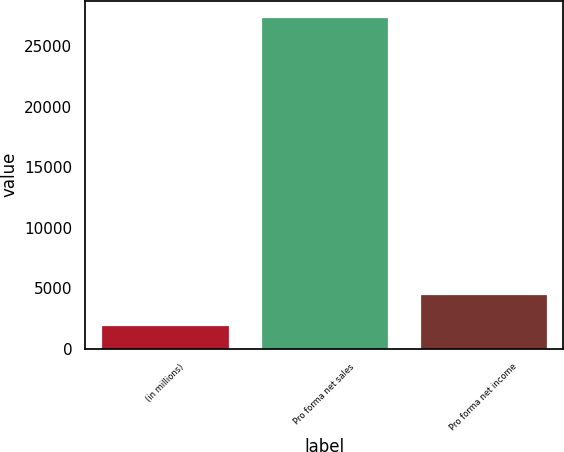Convert chart. <chart><loc_0><loc_0><loc_500><loc_500><bar_chart><fcel>(in millions)<fcel>Pro forma net sales<fcel>Pro forma net income<nl><fcel>2014<fcel>27380<fcel>4550.6<nl></chart> 